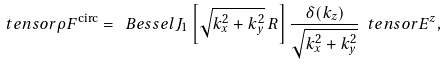<formula> <loc_0><loc_0><loc_500><loc_500>\ t e n s o r { \rho F } ^ { \text {circ} } = \ B e s s e l J _ { 1 } \left [ \sqrt { k _ { x } ^ { 2 } + k _ { y } ^ { 2 } } \, R \right ] \frac { \delta ( k _ { z } ) } { \sqrt { k _ { x } ^ { 2 } + k _ { y } ^ { 2 } } } \ t e n s o r { E } ^ { z } ,</formula> 